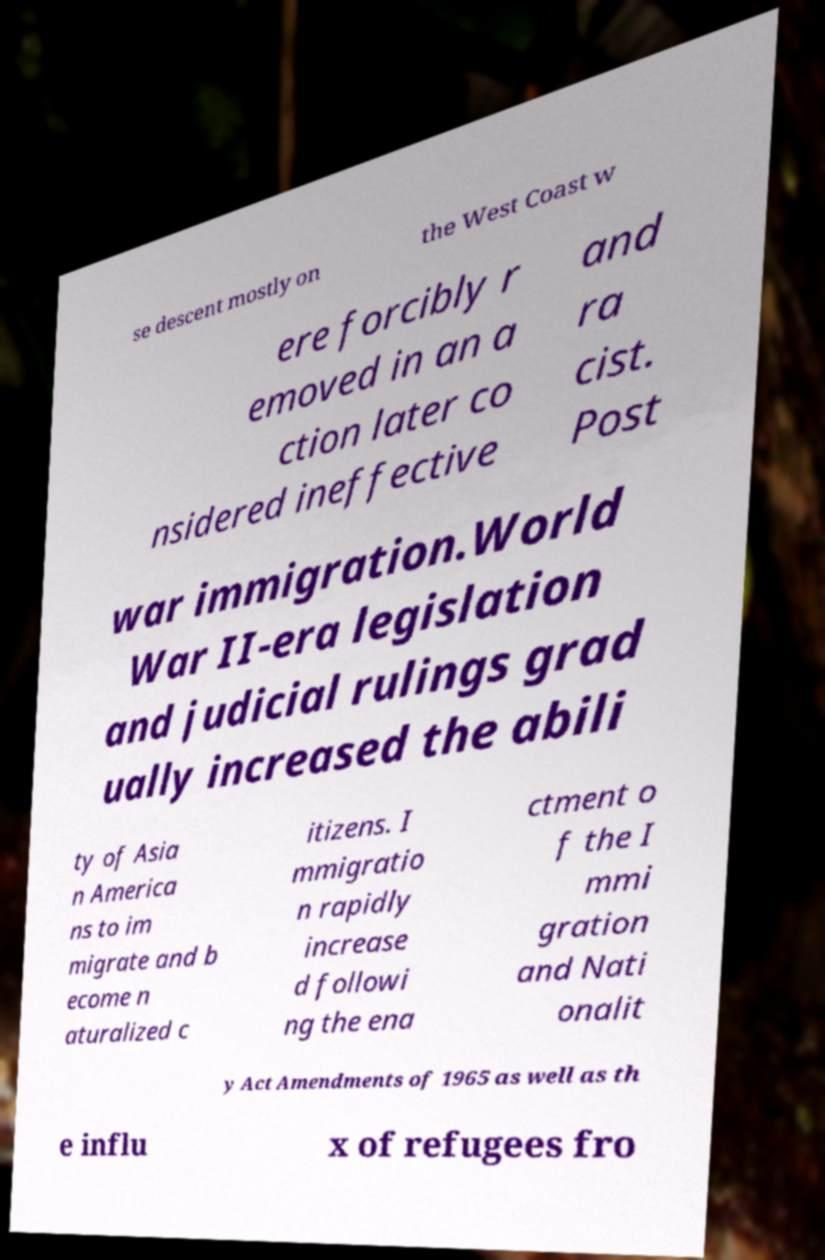What messages or text are displayed in this image? I need them in a readable, typed format. se descent mostly on the West Coast w ere forcibly r emoved in an a ction later co nsidered ineffective and ra cist. Post war immigration.World War II-era legislation and judicial rulings grad ually increased the abili ty of Asia n America ns to im migrate and b ecome n aturalized c itizens. I mmigratio n rapidly increase d followi ng the ena ctment o f the I mmi gration and Nati onalit y Act Amendments of 1965 as well as th e influ x of refugees fro 